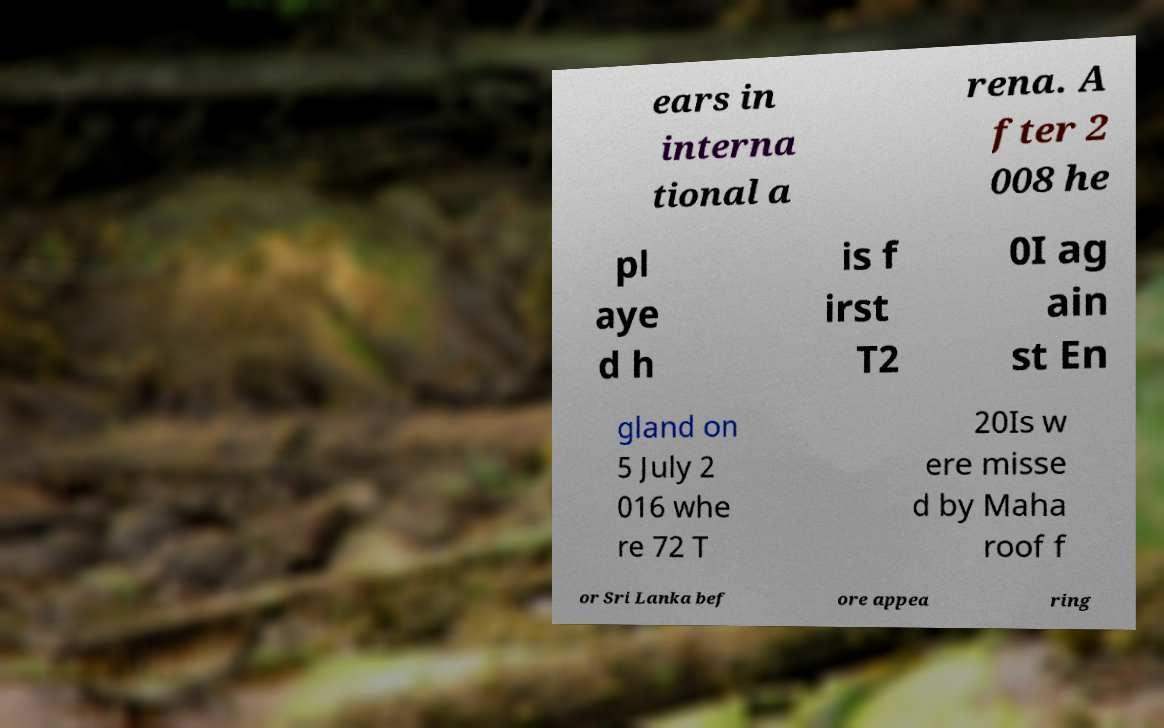Could you assist in decoding the text presented in this image and type it out clearly? ears in interna tional a rena. A fter 2 008 he pl aye d h is f irst T2 0I ag ain st En gland on 5 July 2 016 whe re 72 T 20Is w ere misse d by Maha roof f or Sri Lanka bef ore appea ring 